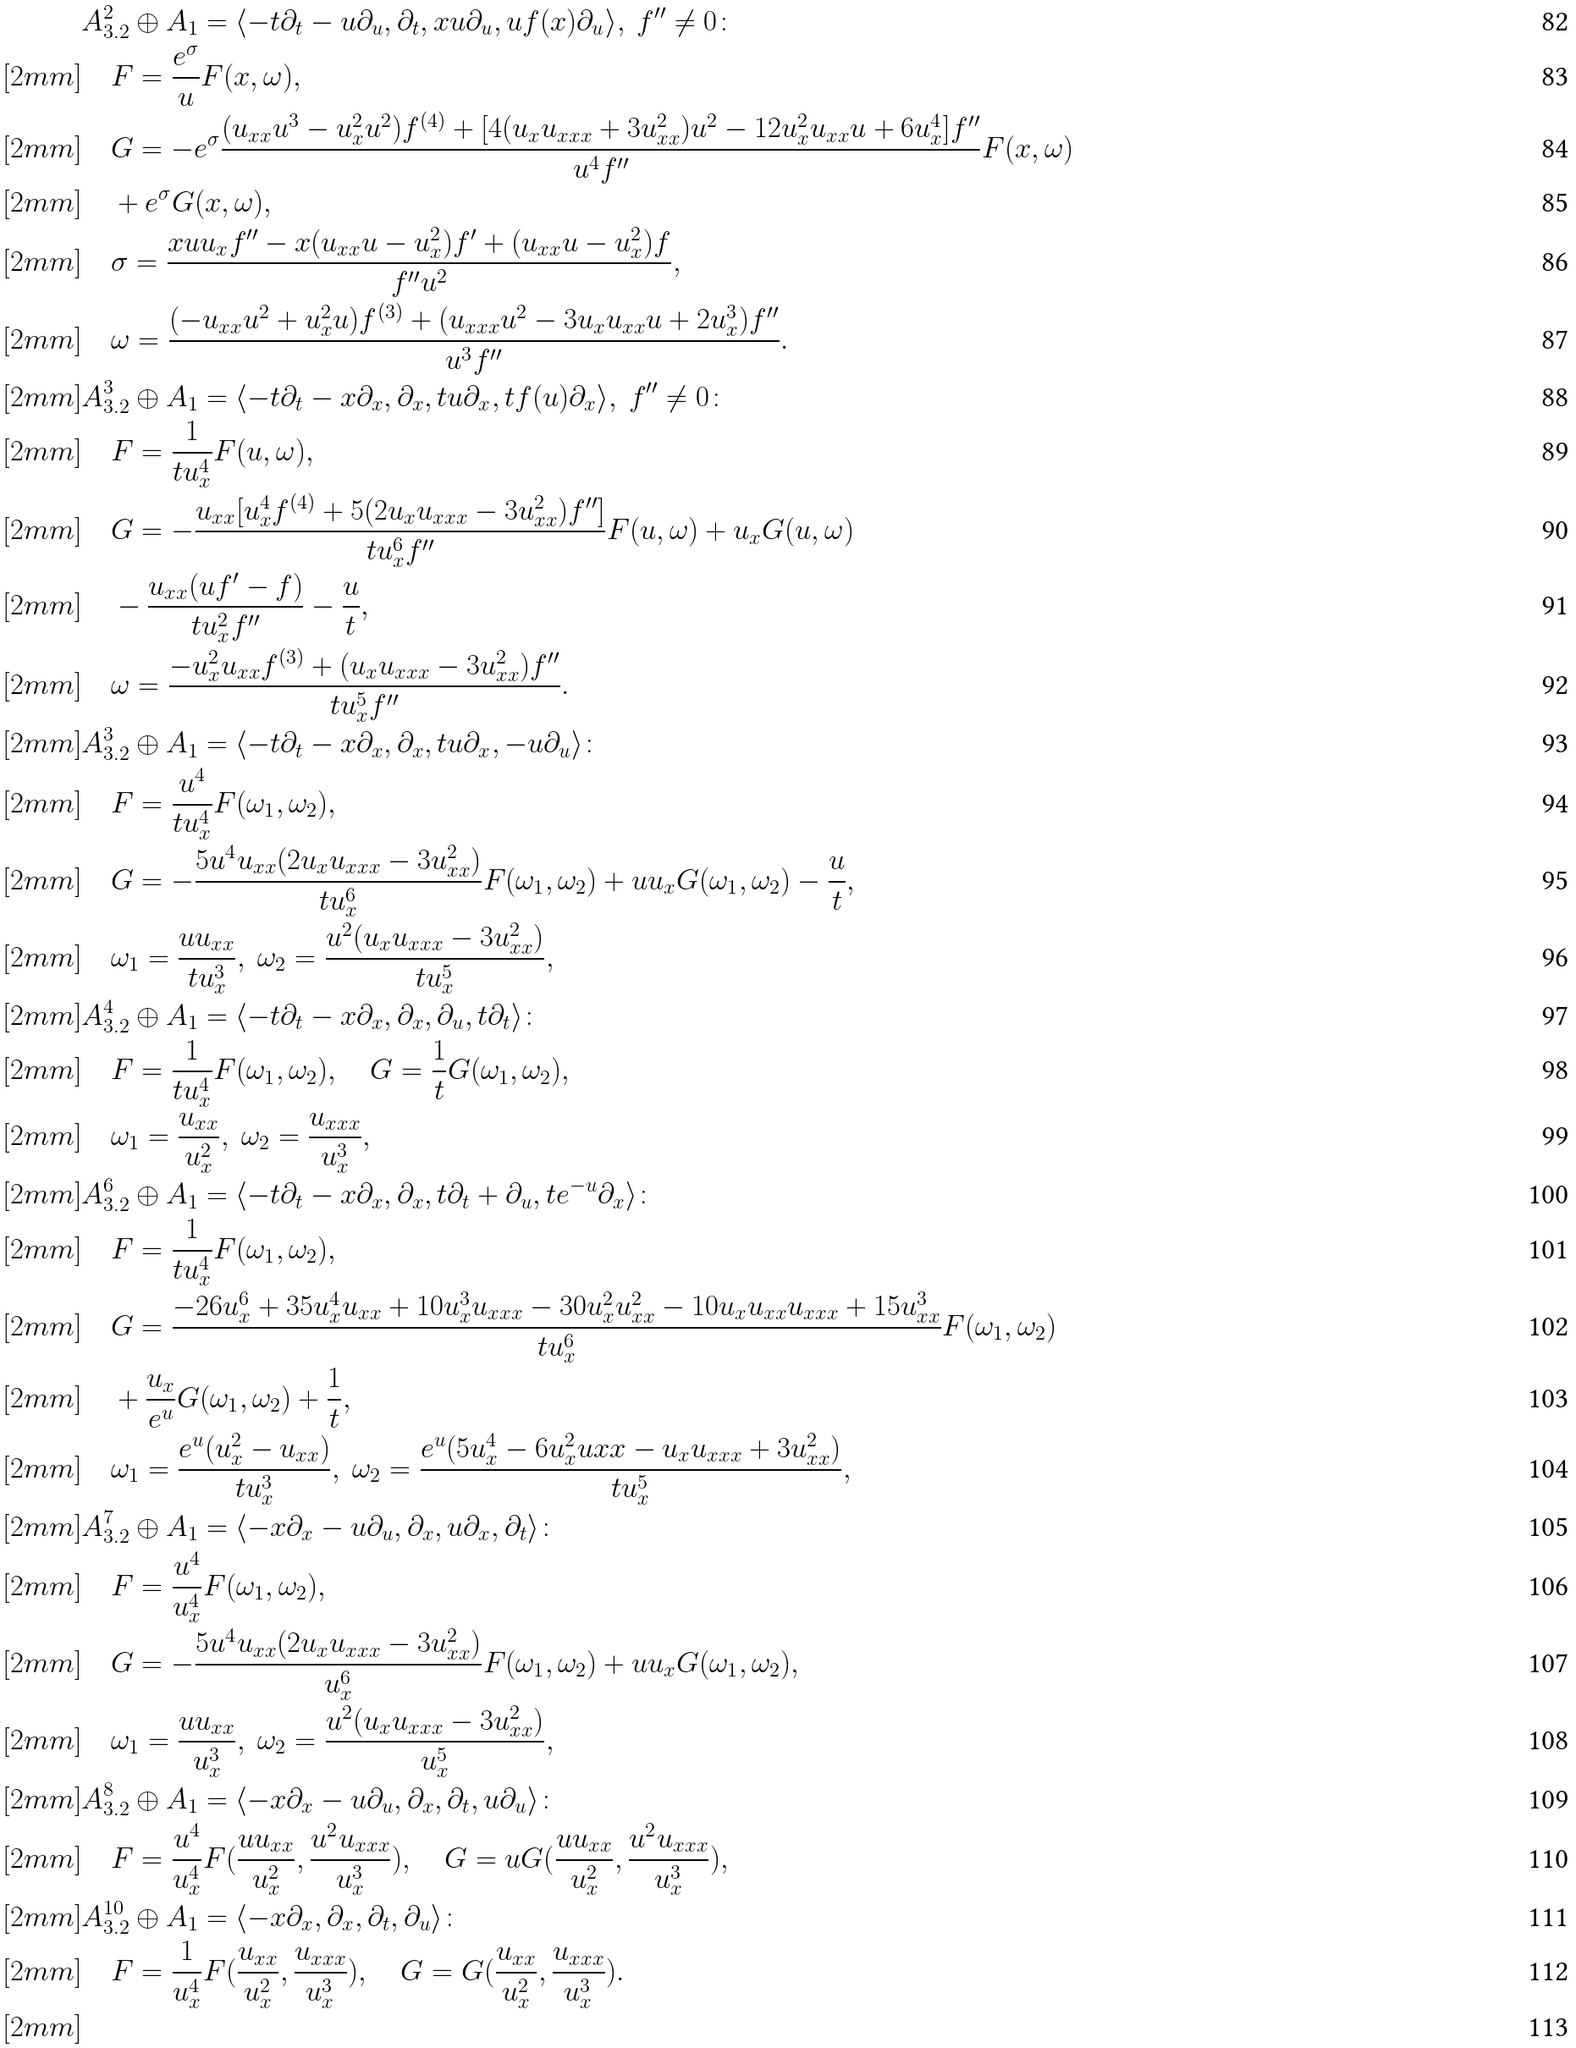Convert formula to latex. <formula><loc_0><loc_0><loc_500><loc_500>& A ^ { 2 } _ { 3 . 2 } \oplus A _ { 1 } = \langle - t \partial _ { t } - u \partial _ { u } , \partial _ { t } , x u \partial _ { u } , u f ( x ) \partial _ { u } \rangle , \ f ^ { \prime \prime } \neq 0 \colon \\ [ 2 m m ] & \quad F = \frac { e ^ { \sigma } } { u } F ( x , \omega ) , \\ [ 2 m m ] & \quad G = - e ^ { \sigma } \frac { ( u _ { x x } u ^ { 3 } - u _ { x } ^ { 2 } u ^ { 2 } ) f ^ { ( 4 ) } + [ 4 ( u _ { x } u _ { x x x } + 3 u _ { x x } ^ { 2 } ) u ^ { 2 } - 1 2 u _ { x } ^ { 2 } u _ { x x } u + 6 u _ { x } ^ { 4 } ] f ^ { \prime \prime } } { u ^ { 4 } f ^ { \prime \prime } } F ( x , \omega ) \\ [ 2 m m ] & \quad + e ^ { \sigma } G ( x , \omega ) , \\ [ 2 m m ] & \quad \sigma = \frac { x u u _ { x } f ^ { \prime \prime } - x ( u _ { x x } u - u _ { x } ^ { 2 } ) f ^ { \prime } + ( u _ { x x } u - u _ { x } ^ { 2 } ) f } { f ^ { \prime \prime } u ^ { 2 } } , \\ [ 2 m m ] & \quad \omega = \frac { ( - u _ { x x } u ^ { 2 } + u _ { x } ^ { 2 } u ) f ^ { ( 3 ) } + ( u _ { x x x } u ^ { 2 } - 3 u _ { x } u _ { x x } u + 2 u _ { x } ^ { 3 } ) f ^ { \prime \prime } } { u ^ { 3 } f ^ { \prime \prime } } . \\ [ 2 m m ] & A ^ { 3 } _ { 3 . 2 } \oplus A _ { 1 } = \langle - t \partial _ { t } - x \partial _ { x } , \partial _ { x } , t u \partial _ { x } , t f ( u ) \partial _ { x } \rangle , \ f ^ { \prime \prime } \neq 0 \colon \\ [ 2 m m ] & \quad F = \frac { 1 } { t u _ { x } ^ { 4 } } F ( u , \omega ) , \\ [ 2 m m ] & \quad G = - \frac { u _ { x x } [ u _ { x } ^ { 4 } f ^ { ( 4 ) } + 5 ( 2 u _ { x } u _ { x x x } - 3 u _ { x x } ^ { 2 } ) f ^ { \prime \prime } ] } { t u _ { x } ^ { 6 } f ^ { \prime \prime } } F ( u , \omega ) + u _ { x } G ( u , \omega ) \\ [ 2 m m ] & \quad - \frac { u _ { x x } ( u f ^ { \prime } - f ) } { t u _ { x } ^ { 2 } f ^ { \prime \prime } } - \frac { u } { t } , \\ [ 2 m m ] & \quad \omega = \frac { - u _ { x } ^ { 2 } u _ { x x } f ^ { ( 3 ) } + ( u _ { x } u _ { x x x } - 3 u _ { x x } ^ { 2 } ) f ^ { \prime \prime } } { t u _ { x } ^ { 5 } f ^ { \prime \prime } } . \\ [ 2 m m ] & A ^ { 3 } _ { 3 . 2 } \oplus A _ { 1 } = \langle - t \partial _ { t } - x \partial _ { x } , \partial _ { x } , t u \partial _ { x } , - u \partial _ { u } \rangle \colon \\ [ 2 m m ] & \quad F = \frac { u ^ { 4 } } { t u _ { x } ^ { 4 } } F ( \omega _ { 1 } , \omega _ { 2 } ) , \\ [ 2 m m ] & \quad G = - \frac { 5 u ^ { 4 } u _ { x x } ( 2 u _ { x } u _ { x x x } - 3 u _ { x x } ^ { 2 } ) } { t u _ { x } ^ { 6 } } F ( \omega _ { 1 } , \omega _ { 2 } ) + u u _ { x } G ( \omega _ { 1 } , \omega _ { 2 } ) - \frac { u } { t } , \\ [ 2 m m ] & \quad \omega _ { 1 } = \frac { u u _ { x x } } { t u _ { x } ^ { 3 } } , \ \omega _ { 2 } = \frac { u ^ { 2 } ( u _ { x } u _ { x x x } - 3 u _ { x x } ^ { 2 } ) } { t u _ { x } ^ { 5 } } , \\ [ 2 m m ] & A ^ { 4 } _ { 3 . 2 } \oplus A _ { 1 } = \langle - t \partial _ { t } - x \partial _ { x } , \partial _ { x } , \partial _ { u } , t \partial _ { t } \rangle \colon \\ [ 2 m m ] & \quad F = \frac { 1 } { t u _ { x } ^ { 4 } } F ( \omega _ { 1 } , \omega _ { 2 } ) , \quad G = \frac { 1 } { t } G ( \omega _ { 1 } , \omega _ { 2 } ) , \\ [ 2 m m ] & \quad \omega _ { 1 } = \frac { u _ { x x } } { u _ { x } ^ { 2 } } , \ \omega _ { 2 } = \frac { u _ { x x x } } { u _ { x } ^ { 3 } } , \\ [ 2 m m ] & A ^ { 6 } _ { 3 . 2 } \oplus A _ { 1 } = \langle - t \partial _ { t } - x \partial _ { x } , \partial _ { x } , t \partial _ { t } + \partial _ { u } , t e ^ { - u } \partial _ { x } \rangle \colon \\ [ 2 m m ] & \quad F = \frac { 1 } { t u _ { x } ^ { 4 } } F ( \omega _ { 1 } , \omega _ { 2 } ) , \\ [ 2 m m ] & \quad G = \frac { - 2 6 u _ { x } ^ { 6 } + 3 5 u _ { x } ^ { 4 } u _ { x x } + 1 0 u _ { x } ^ { 3 } u _ { x x x } - 3 0 u _ { x } ^ { 2 } u _ { x x } ^ { 2 } - 1 0 u _ { x } u _ { x x } u _ { x x x } + 1 5 u _ { x x } ^ { 3 } } { t u _ { x } ^ { 6 } } F ( \omega _ { 1 } , \omega _ { 2 } ) \\ [ 2 m m ] & \quad + \frac { u _ { x } } { e ^ { u } } G ( \omega _ { 1 } , \omega _ { 2 } ) + \frac { 1 } { t } , \\ [ 2 m m ] & \quad \omega _ { 1 } = \frac { e ^ { u } ( u _ { x } ^ { 2 } - u _ { x x } ) } { t u _ { x } ^ { 3 } } , \ \omega _ { 2 } = \frac { e ^ { u } ( 5 u _ { x } ^ { 4 } - 6 u _ { x } ^ { 2 } u { x x } - u _ { x } u _ { x x x } + 3 u _ { x x } ^ { 2 } ) } { t u _ { x } ^ { 5 } } , \\ [ 2 m m ] & A ^ { 7 } _ { 3 . 2 } \oplus A _ { 1 } = \langle - x \partial _ { x } - u \partial _ { u } , \partial _ { x } , u \partial _ { x } , \partial _ { t } \rangle \colon \\ [ 2 m m ] & \quad F = \frac { u ^ { 4 } } { u _ { x } ^ { 4 } } F ( \omega _ { 1 } , \omega _ { 2 } ) , \\ [ 2 m m ] & \quad G = - \frac { 5 u ^ { 4 } u _ { x x } ( 2 u _ { x } u _ { x x x } - 3 u _ { x x } ^ { 2 } ) } { u _ { x } ^ { 6 } } F ( \omega _ { 1 } , \omega _ { 2 } ) + u u _ { x } G ( \omega _ { 1 } , \omega _ { 2 } ) , \\ [ 2 m m ] & \quad \omega _ { 1 } = \frac { u u _ { x x } } { u _ { x } ^ { 3 } } , \ \omega _ { 2 } = \frac { u ^ { 2 } ( u _ { x } u _ { x x x } - 3 u _ { x x } ^ { 2 } ) } { u _ { x } ^ { 5 } } , \\ [ 2 m m ] & A ^ { 8 } _ { 3 . 2 } \oplus A _ { 1 } = \langle - x \partial _ { x } - u \partial _ { u } , \partial _ { x } , \partial _ { t } , u \partial _ { u } \rangle \colon \\ [ 2 m m ] & \quad F = \frac { u ^ { 4 } } { u _ { x } ^ { 4 } } F ( \frac { u u _ { x x } } { u _ { x } ^ { 2 } } , \frac { u ^ { 2 } u _ { x x x } } { u _ { x } ^ { 3 } } ) , \quad G = u G ( \frac { u u _ { x x } } { u _ { x } ^ { 2 } } , \frac { u ^ { 2 } u _ { x x x } } { u _ { x } ^ { 3 } } ) , \\ [ 2 m m ] & A ^ { 1 0 } _ { 3 . 2 } \oplus A _ { 1 } = \langle - x \partial _ { x } , \partial _ { x } , \partial _ { t } , \partial _ { u } \rangle \colon \\ [ 2 m m ] & \quad F = \frac { 1 } { u _ { x } ^ { 4 } } F ( \frac { u _ { x x } } { u _ { x } ^ { 2 } } , \frac { u _ { x x x } } { u _ { x } ^ { 3 } } ) , \quad G = G ( \frac { u _ { x x } } { u _ { x } ^ { 2 } } , \frac { u _ { x x x } } { u _ { x } ^ { 3 } } ) . \\ [ 2 m m ]</formula> 